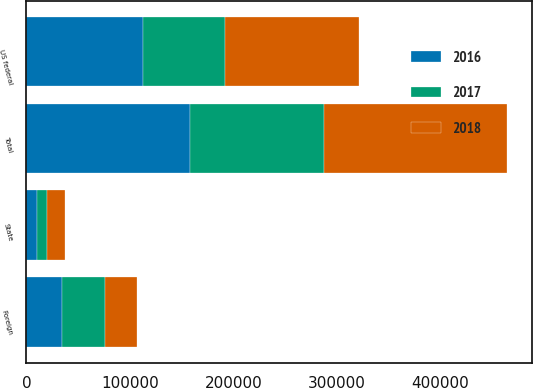Convert chart to OTSL. <chart><loc_0><loc_0><loc_500><loc_500><stacked_bar_chart><ecel><fcel>US federal<fcel>State<fcel>Foreign<fcel>Total<nl><fcel>2017<fcel>78454<fcel>9800<fcel>41040<fcel>129294<nl><fcel>2016<fcel>113105<fcel>10381<fcel>34679<fcel>158165<nl><fcel>2018<fcel>129728<fcel>16821<fcel>31015<fcel>177564<nl></chart> 